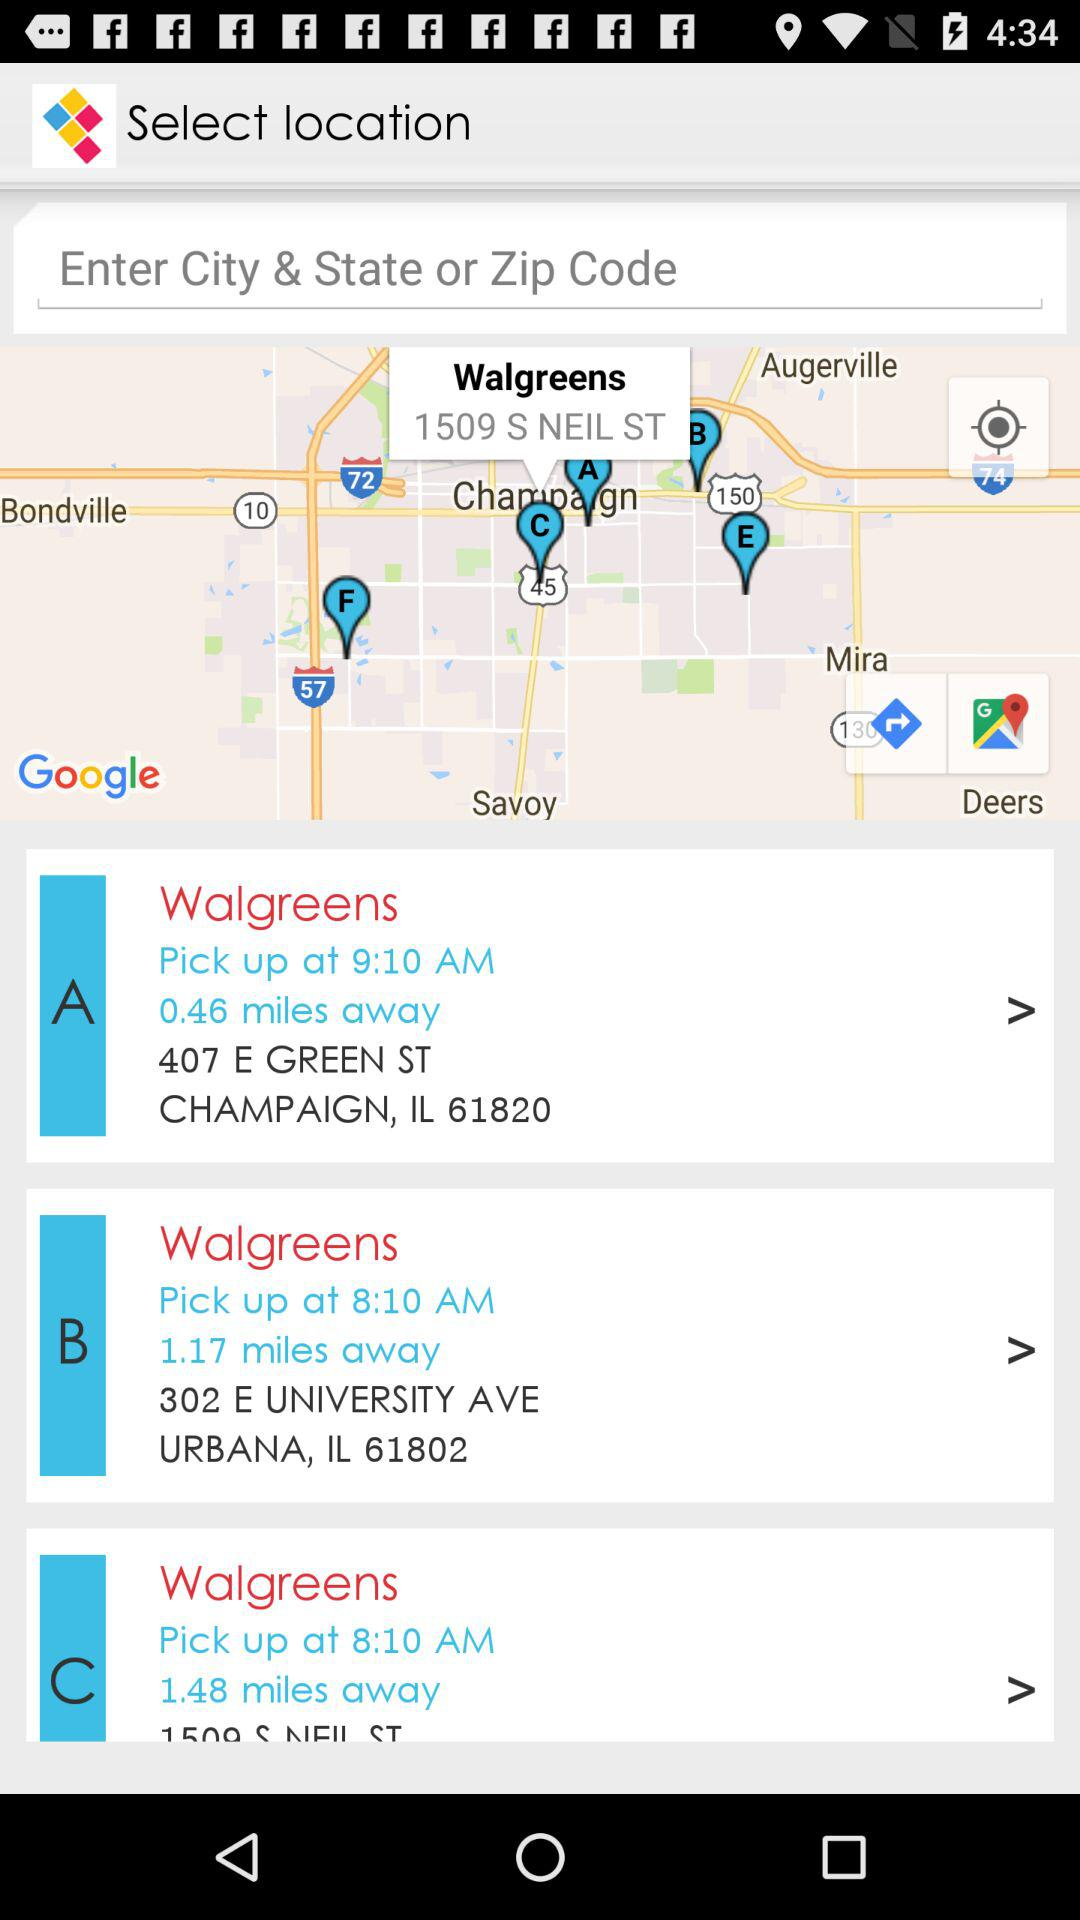At which location has the pickup time of 8:10 am? The location is 302 E University Ave, Urbana, IL 61802. 